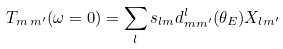<formula> <loc_0><loc_0><loc_500><loc_500>T _ { m \, m ^ { \prime } } ( \omega = 0 ) = \sum _ { l } s _ { l m } d ^ { l } _ { m m ^ { \prime } } ( \theta _ { E } ) X _ { l m ^ { \prime } }</formula> 